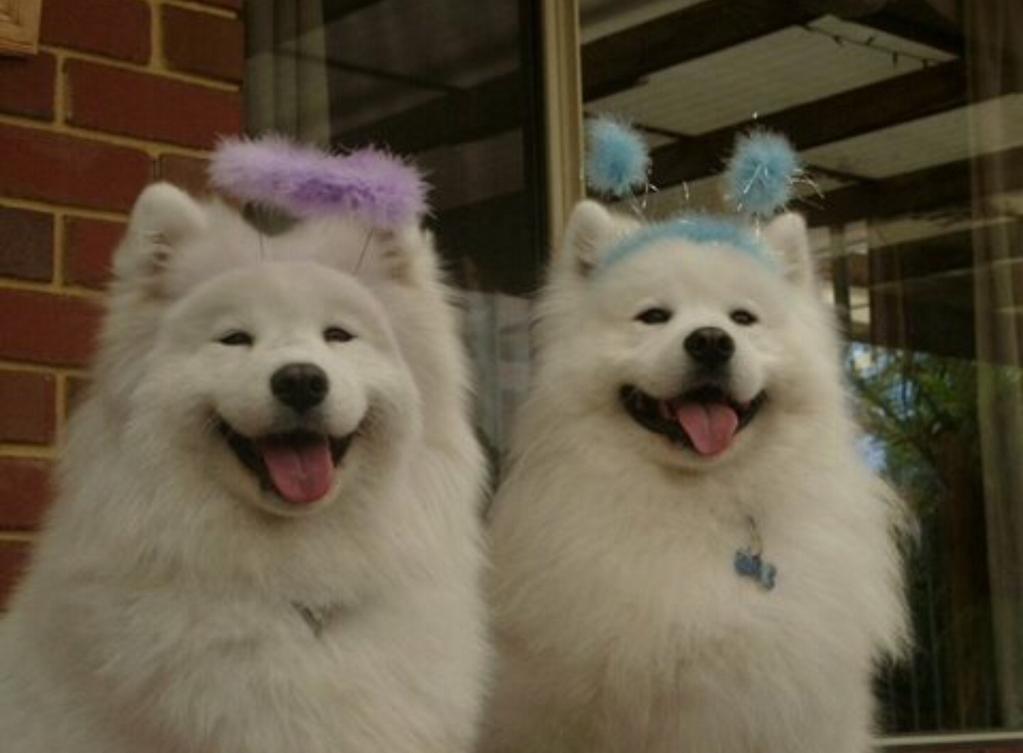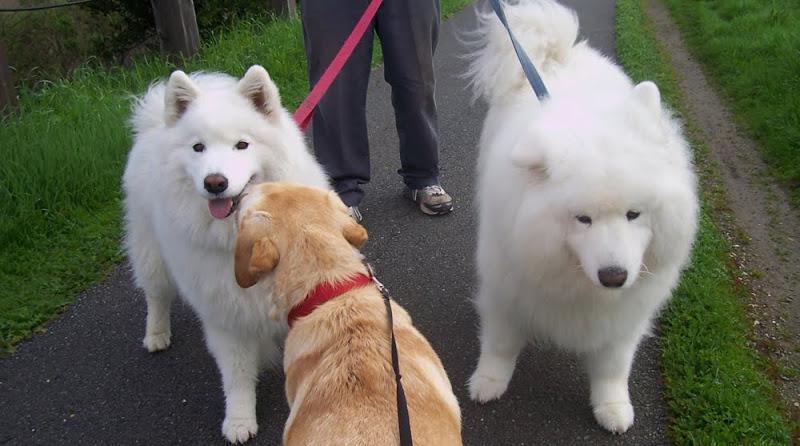The first image is the image on the left, the second image is the image on the right. Evaluate the accuracy of this statement regarding the images: "In at least one image there are no less than four dogs with a white chest fur standing in a line next to each other on grass.". Is it true? Answer yes or no. No. The first image is the image on the left, the second image is the image on the right. For the images shown, is this caption "In one of the images, there are two white dogs and at least one dog of another color." true? Answer yes or no. Yes. 